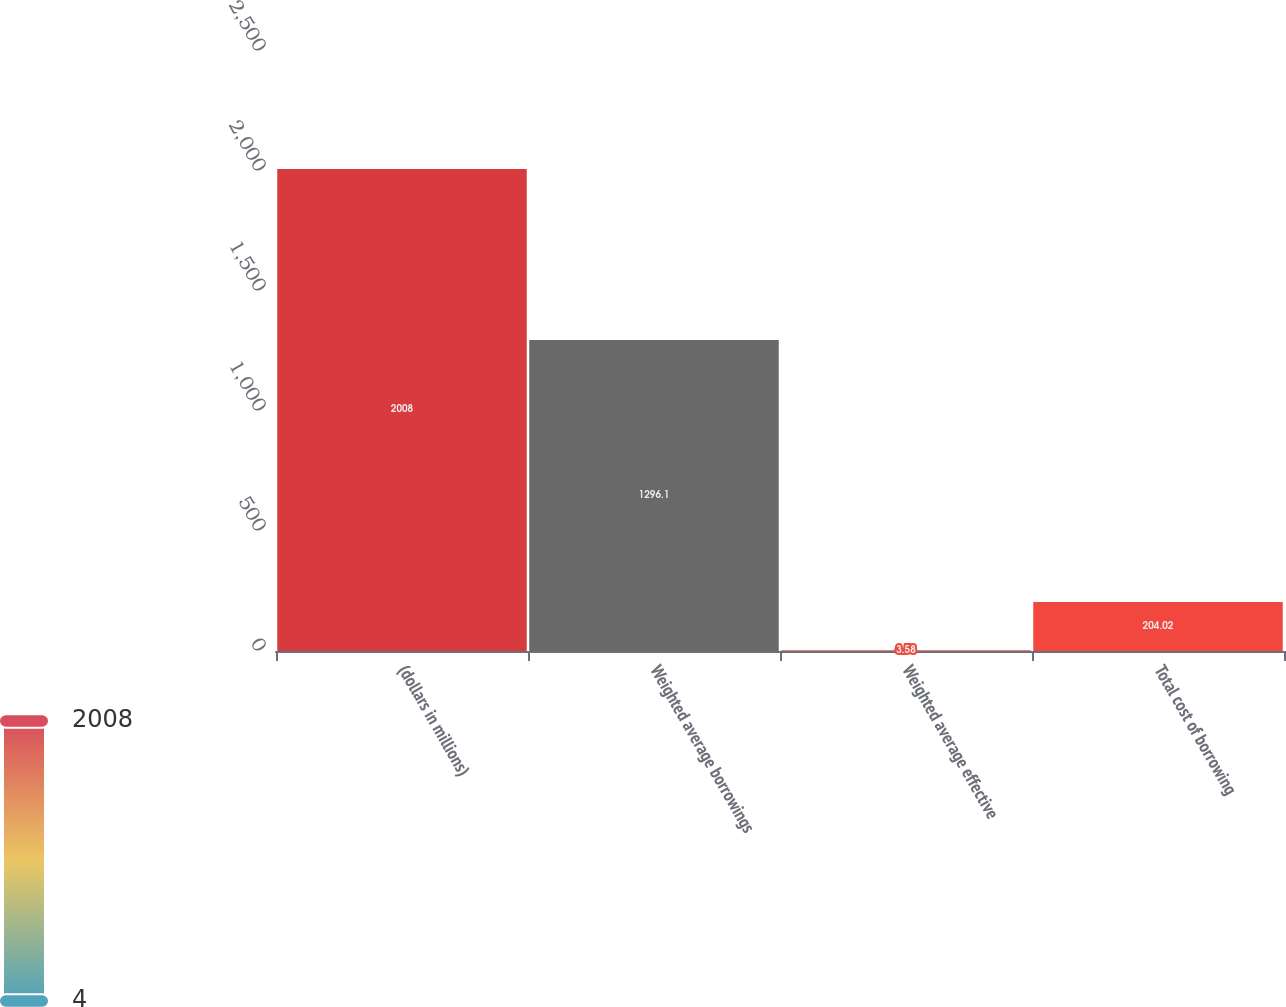Convert chart to OTSL. <chart><loc_0><loc_0><loc_500><loc_500><bar_chart><fcel>(dollars in millions)<fcel>Weighted average borrowings<fcel>Weighted average effective<fcel>Total cost of borrowing<nl><fcel>2008<fcel>1296.1<fcel>3.58<fcel>204.02<nl></chart> 